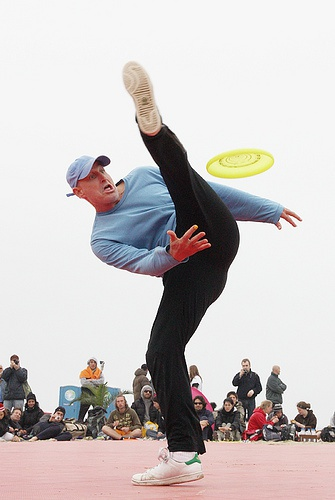Describe the objects in this image and their specific colors. I can see people in white, black, and gray tones, people in white, black, lightgray, gray, and darkgray tones, frisbee in whitesmoke, khaki, ivory, and gold tones, people in white, gray, and tan tones, and people in whitesmoke, black, gray, and white tones in this image. 